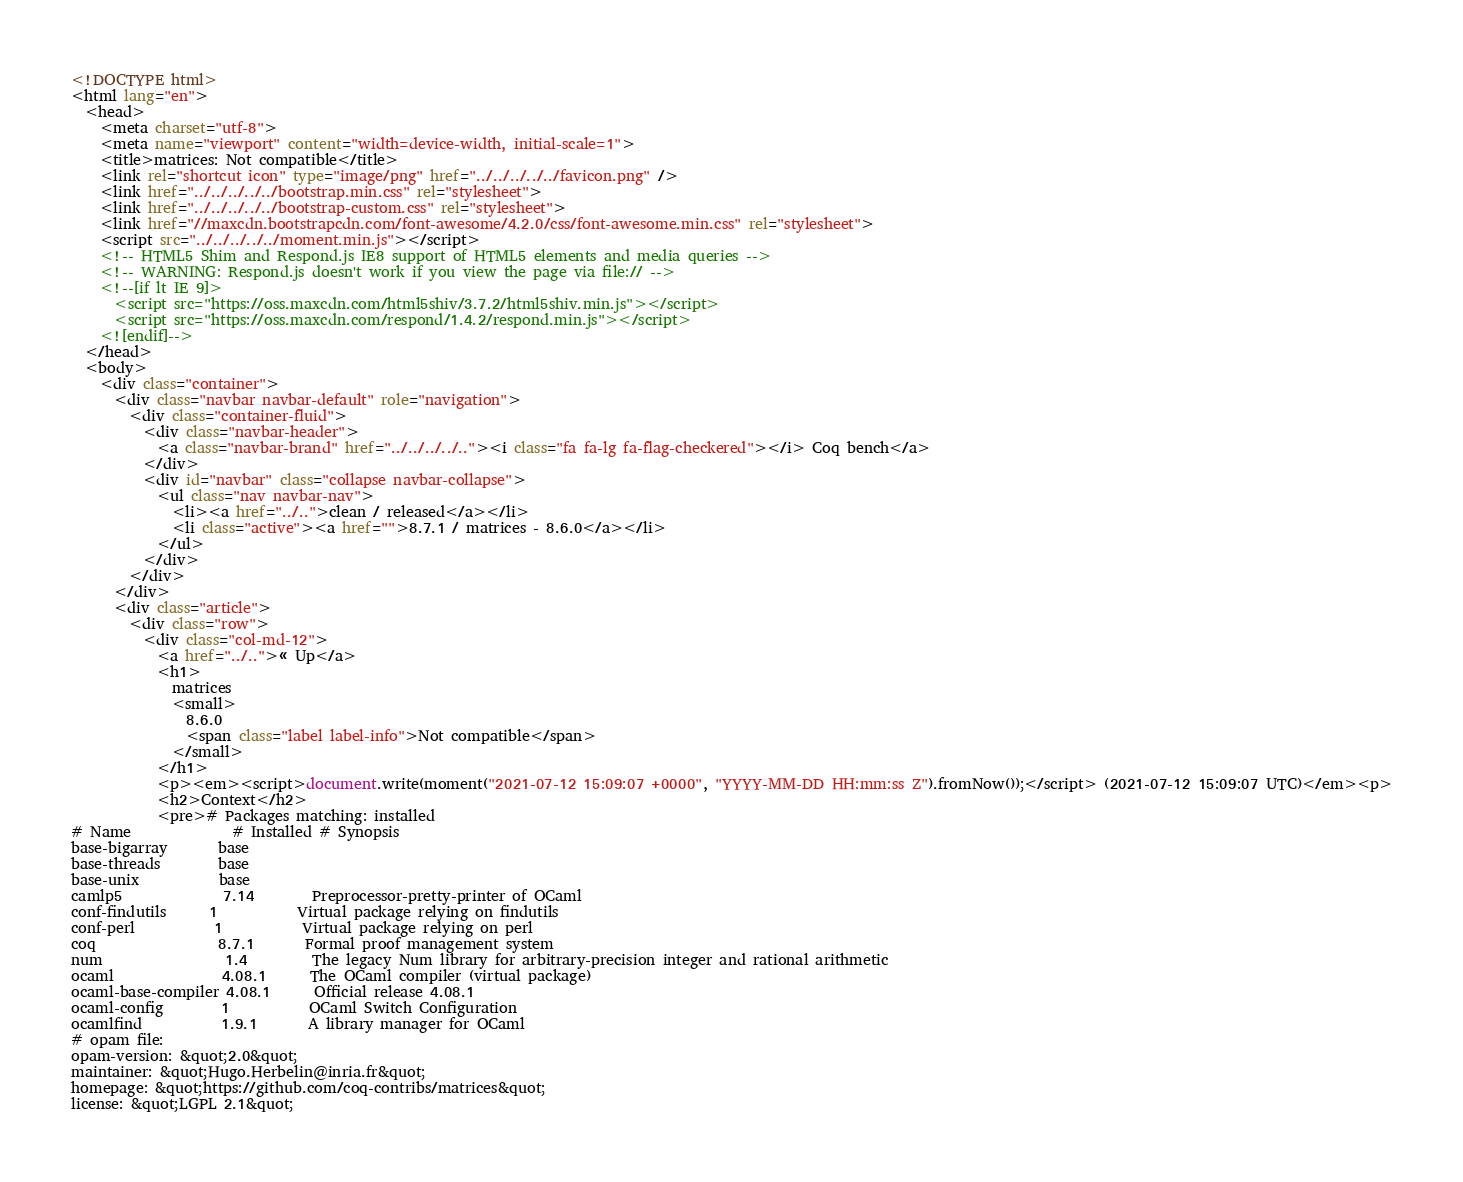<code> <loc_0><loc_0><loc_500><loc_500><_HTML_><!DOCTYPE html>
<html lang="en">
  <head>
    <meta charset="utf-8">
    <meta name="viewport" content="width=device-width, initial-scale=1">
    <title>matrices: Not compatible</title>
    <link rel="shortcut icon" type="image/png" href="../../../../../favicon.png" />
    <link href="../../../../../bootstrap.min.css" rel="stylesheet">
    <link href="../../../../../bootstrap-custom.css" rel="stylesheet">
    <link href="//maxcdn.bootstrapcdn.com/font-awesome/4.2.0/css/font-awesome.min.css" rel="stylesheet">
    <script src="../../../../../moment.min.js"></script>
    <!-- HTML5 Shim and Respond.js IE8 support of HTML5 elements and media queries -->
    <!-- WARNING: Respond.js doesn't work if you view the page via file:// -->
    <!--[if lt IE 9]>
      <script src="https://oss.maxcdn.com/html5shiv/3.7.2/html5shiv.min.js"></script>
      <script src="https://oss.maxcdn.com/respond/1.4.2/respond.min.js"></script>
    <![endif]-->
  </head>
  <body>
    <div class="container">
      <div class="navbar navbar-default" role="navigation">
        <div class="container-fluid">
          <div class="navbar-header">
            <a class="navbar-brand" href="../../../../.."><i class="fa fa-lg fa-flag-checkered"></i> Coq bench</a>
          </div>
          <div id="navbar" class="collapse navbar-collapse">
            <ul class="nav navbar-nav">
              <li><a href="../..">clean / released</a></li>
              <li class="active"><a href="">8.7.1 / matrices - 8.6.0</a></li>
            </ul>
          </div>
        </div>
      </div>
      <div class="article">
        <div class="row">
          <div class="col-md-12">
            <a href="../..">« Up</a>
            <h1>
              matrices
              <small>
                8.6.0
                <span class="label label-info">Not compatible</span>
              </small>
            </h1>
            <p><em><script>document.write(moment("2021-07-12 15:09:07 +0000", "YYYY-MM-DD HH:mm:ss Z").fromNow());</script> (2021-07-12 15:09:07 UTC)</em><p>
            <h2>Context</h2>
            <pre># Packages matching: installed
# Name              # Installed # Synopsis
base-bigarray       base
base-threads        base
base-unix           base
camlp5              7.14        Preprocessor-pretty-printer of OCaml
conf-findutils      1           Virtual package relying on findutils
conf-perl           1           Virtual package relying on perl
coq                 8.7.1       Formal proof management system
num                 1.4         The legacy Num library for arbitrary-precision integer and rational arithmetic
ocaml               4.08.1      The OCaml compiler (virtual package)
ocaml-base-compiler 4.08.1      Official release 4.08.1
ocaml-config        1           OCaml Switch Configuration
ocamlfind           1.9.1       A library manager for OCaml
# opam file:
opam-version: &quot;2.0&quot;
maintainer: &quot;Hugo.Herbelin@inria.fr&quot;
homepage: &quot;https://github.com/coq-contribs/matrices&quot;
license: &quot;LGPL 2.1&quot;</code> 